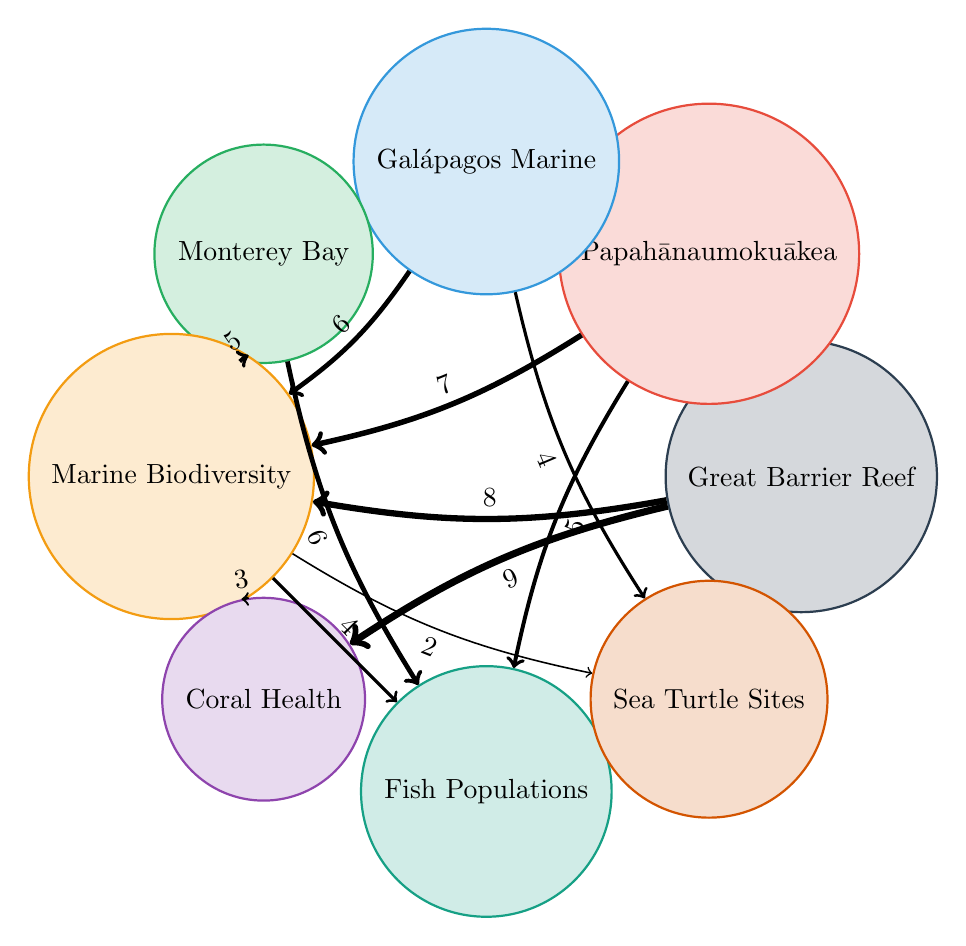What is the value assigned to Marine Biodiversity from the Great Barrier Reef Marine Park? By examining the link between the Great Barrier Reef Marine Park and Marine Biodiversity, we see the value is 8.
Answer: 8 Which marine protected area has the highest connection to Coral Health? The Great Barrier Reef Marine Park has the strongest connection to Coral Health, indicated by a value of 9, which is the highest among the connections displayed.
Answer: Great Barrier Reef Marine Park How many links are directed towards Marine Biodiversity? By counting the outgoing links from Marine Biodiversity, we find three: to Coral Health, Fish Populations, and Sea Turtle Nesting Sites. Thus, there are three links directed towards Marine Biodiversity itself.
Answer: 3 Which marine protected area has the lowest value for connections? Galápagos Marine Reserve has the lowest value connection to Sea Turtle Nesting Sites, with a value of 4, which is the least among the marine protected areas.
Answer: Galápagos Marine Reserve What is the total connection value between the Papahānaumokuākea Marine National Monument and both Marine Biodiversity and Fish Populations? The connection value to Marine Biodiversity from Papahānaumokukea is 7, and the connection value to Fish Populations is 5. Adding these together gives us a total of 12.
Answer: 12 Which two factors are linked to the Galápagos Marine Reserve, and what are their connection values? Galápagos Marine Reserve links to Marine Biodiversity with a value of 6 and to Sea Turtle Nesting Sites with a value of 4. The eventual connections from this protected area total two distinct factors with defined values.
Answer: Marine Biodiversity (6), Sea Turtle Nesting Sites (4) How does the connection from Monterey Bay National Marine Sanctuary to Fish Populations compare to its connection to Marine Biodiversity? The connection from Monterey Bay National Marine Sanctuary to Fish Populations has a value of 6, while the connection to Marine Biodiversity has a value of 5, indicating a stronger connection to Fish Populations.
Answer: Fish Populations (6) stronger than Marine Biodiversity (5) Which node serves as the central point among the four marine protected areas in terms of connection strength? Marine Biodiversity acts as the central point, connecting to all four protected areas, with varying connection strengths that illustrate its importance in linking these locations.
Answer: Marine Biodiversity How many total connection values do we find from the Great Barrier Reef Marine Park? The Great Barrier Reef Marine Park has two connections leading into Marine Biodiversity and Coral Health, totaling two direct connections identified within the diagram.
Answer: 2 